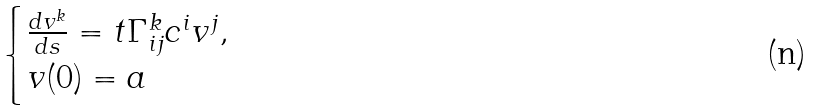Convert formula to latex. <formula><loc_0><loc_0><loc_500><loc_500>\begin{cases} \frac { d v ^ { k } } { d s } = t \Gamma _ { i j } ^ { k } c ^ { i } v ^ { j } , \\ v ( 0 ) = a \end{cases}</formula> 